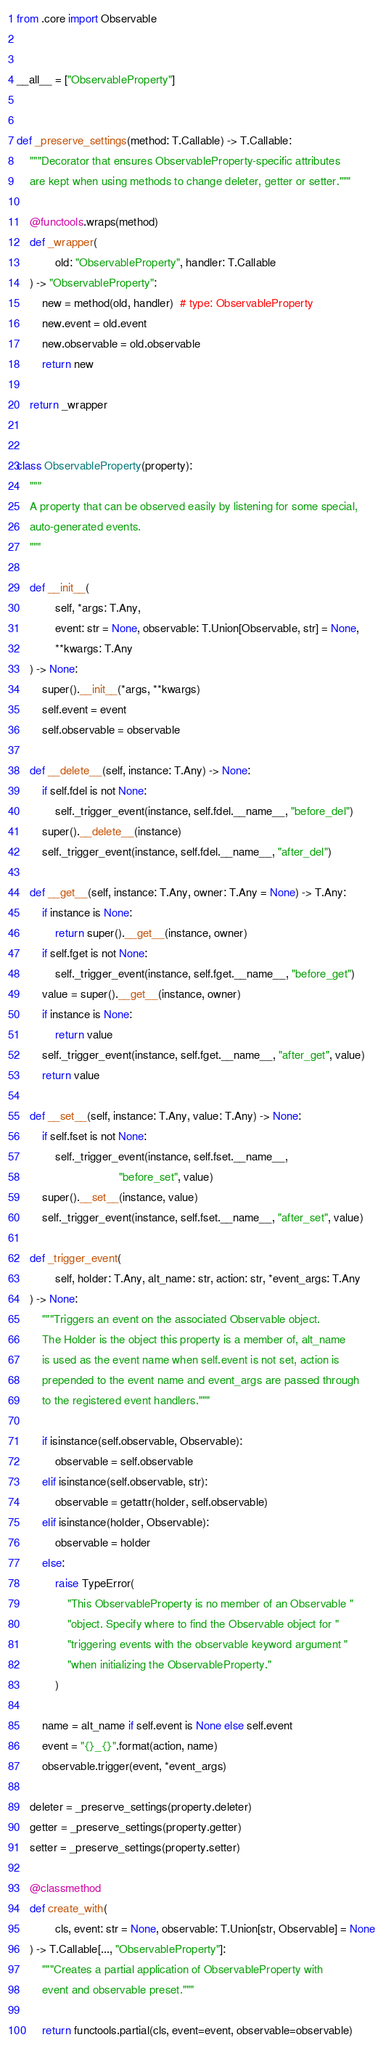<code> <loc_0><loc_0><loc_500><loc_500><_Python_>
from .core import Observable


__all__ = ["ObservableProperty"]


def _preserve_settings(method: T.Callable) -> T.Callable:
    """Decorator that ensures ObservableProperty-specific attributes
    are kept when using methods to change deleter, getter or setter."""

    @functools.wraps(method)
    def _wrapper(
            old: "ObservableProperty", handler: T.Callable
    ) -> "ObservableProperty":
        new = method(old, handler)  # type: ObservableProperty
        new.event = old.event
        new.observable = old.observable
        return new

    return _wrapper


class ObservableProperty(property):
    """
    A property that can be observed easily by listening for some special,
    auto-generated events.
    """

    def __init__(
            self, *args: T.Any,
            event: str = None, observable: T.Union[Observable, str] = None,
            **kwargs: T.Any
    ) -> None:
        super().__init__(*args, **kwargs)
        self.event = event
        self.observable = observable

    def __delete__(self, instance: T.Any) -> None:
        if self.fdel is not None:
            self._trigger_event(instance, self.fdel.__name__, "before_del")
        super().__delete__(instance)
        self._trigger_event(instance, self.fdel.__name__, "after_del")

    def __get__(self, instance: T.Any, owner: T.Any = None) -> T.Any:
        if instance is None:
            return super().__get__(instance, owner)
        if self.fget is not None:
            self._trigger_event(instance, self.fget.__name__, "before_get")
        value = super().__get__(instance, owner)
        if instance is None:
            return value
        self._trigger_event(instance, self.fget.__name__, "after_get", value)
        return value

    def __set__(self, instance: T.Any, value: T.Any) -> None:
        if self.fset is not None:
            self._trigger_event(instance, self.fset.__name__,
                                "before_set", value)
        super().__set__(instance, value)
        self._trigger_event(instance, self.fset.__name__, "after_set", value)

    def _trigger_event(
            self, holder: T.Any, alt_name: str, action: str, *event_args: T.Any
    ) -> None:
        """Triggers an event on the associated Observable object.
        The Holder is the object this property is a member of, alt_name
        is used as the event name when self.event is not set, action is
        prepended to the event name and event_args are passed through
        to the registered event handlers."""

        if isinstance(self.observable, Observable):
            observable = self.observable
        elif isinstance(self.observable, str):
            observable = getattr(holder, self.observable)
        elif isinstance(holder, Observable):
            observable = holder
        else:
            raise TypeError(
                "This ObservableProperty is no member of an Observable "
                "object. Specify where to find the Observable object for "
                "triggering events with the observable keyword argument "
                "when initializing the ObservableProperty."
            )

        name = alt_name if self.event is None else self.event
        event = "{}_{}".format(action, name)
        observable.trigger(event, *event_args)

    deleter = _preserve_settings(property.deleter)
    getter = _preserve_settings(property.getter)
    setter = _preserve_settings(property.setter)

    @classmethod
    def create_with(
            cls, event: str = None, observable: T.Union[str, Observable] = None
    ) -> T.Callable[..., "ObservableProperty"]:
        """Creates a partial application of ObservableProperty with
        event and observable preset."""

        return functools.partial(cls, event=event, observable=observable)
</code> 